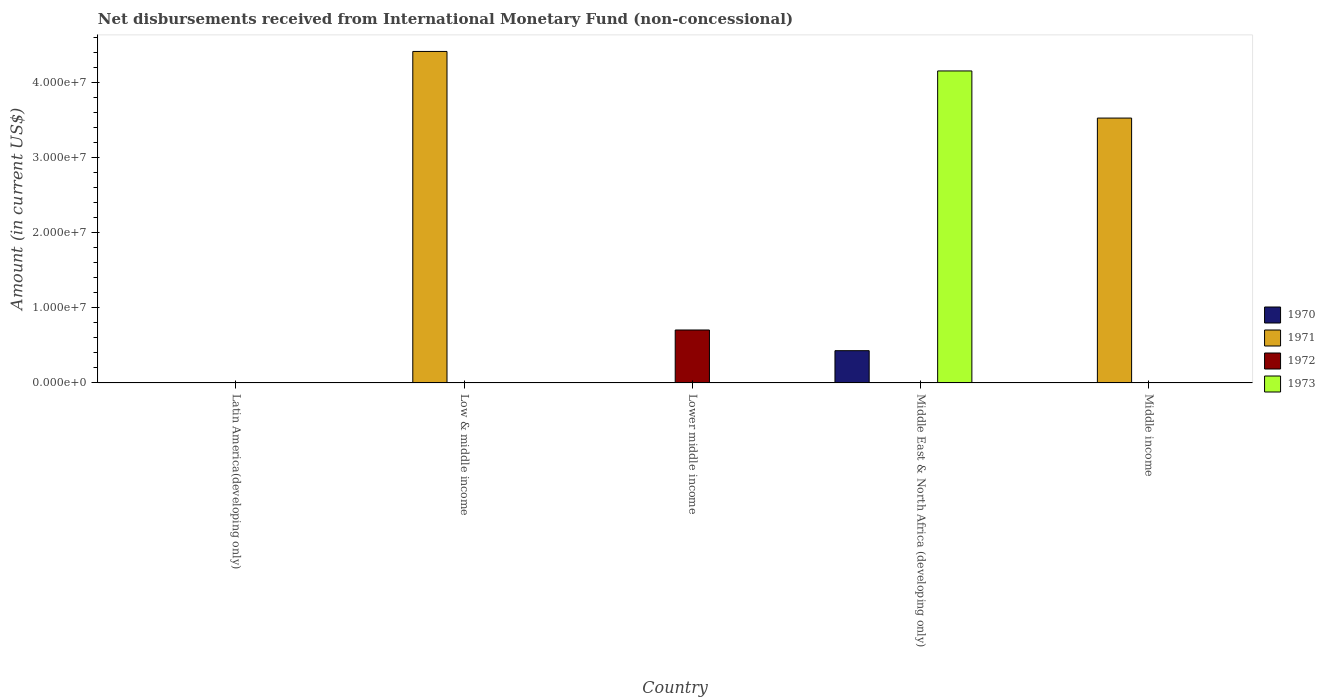How many different coloured bars are there?
Your answer should be compact. 4. What is the label of the 1st group of bars from the left?
Make the answer very short. Latin America(developing only). What is the amount of disbursements received from International Monetary Fund in 1970 in Lower middle income?
Keep it short and to the point. 0. Across all countries, what is the maximum amount of disbursements received from International Monetary Fund in 1973?
Offer a terse response. 4.16e+07. Across all countries, what is the minimum amount of disbursements received from International Monetary Fund in 1972?
Your answer should be very brief. 0. In which country was the amount of disbursements received from International Monetary Fund in 1970 maximum?
Offer a terse response. Middle East & North Africa (developing only). What is the total amount of disbursements received from International Monetary Fund in 1971 in the graph?
Your answer should be compact. 7.95e+07. What is the difference between the amount of disbursements received from International Monetary Fund in 1971 in Low & middle income and that in Middle income?
Offer a terse response. 8.88e+06. What is the difference between the amount of disbursements received from International Monetary Fund in 1972 in Latin America(developing only) and the amount of disbursements received from International Monetary Fund in 1970 in Low & middle income?
Keep it short and to the point. 0. What is the average amount of disbursements received from International Monetary Fund in 1970 per country?
Offer a very short reply. 8.60e+05. What is the difference between the amount of disbursements received from International Monetary Fund of/in 1973 and amount of disbursements received from International Monetary Fund of/in 1970 in Middle East & North Africa (developing only)?
Provide a succinct answer. 3.73e+07. What is the difference between the highest and the lowest amount of disbursements received from International Monetary Fund in 1970?
Ensure brevity in your answer.  4.30e+06. In how many countries, is the amount of disbursements received from International Monetary Fund in 1973 greater than the average amount of disbursements received from International Monetary Fund in 1973 taken over all countries?
Your answer should be compact. 1. Is it the case that in every country, the sum of the amount of disbursements received from International Monetary Fund in 1973 and amount of disbursements received from International Monetary Fund in 1970 is greater than the sum of amount of disbursements received from International Monetary Fund in 1972 and amount of disbursements received from International Monetary Fund in 1971?
Your response must be concise. No. Is it the case that in every country, the sum of the amount of disbursements received from International Monetary Fund in 1971 and amount of disbursements received from International Monetary Fund in 1972 is greater than the amount of disbursements received from International Monetary Fund in 1973?
Offer a terse response. No. Are all the bars in the graph horizontal?
Make the answer very short. No. Are the values on the major ticks of Y-axis written in scientific E-notation?
Make the answer very short. Yes. Does the graph contain any zero values?
Offer a very short reply. Yes. Does the graph contain grids?
Offer a terse response. No. Where does the legend appear in the graph?
Make the answer very short. Center right. What is the title of the graph?
Provide a short and direct response. Net disbursements received from International Monetary Fund (non-concessional). What is the label or title of the X-axis?
Give a very brief answer. Country. What is the label or title of the Y-axis?
Provide a short and direct response. Amount (in current US$). What is the Amount (in current US$) in 1970 in Latin America(developing only)?
Your answer should be very brief. 0. What is the Amount (in current US$) in 1971 in Latin America(developing only)?
Give a very brief answer. 0. What is the Amount (in current US$) in 1971 in Low & middle income?
Ensure brevity in your answer.  4.42e+07. What is the Amount (in current US$) of 1973 in Low & middle income?
Make the answer very short. 0. What is the Amount (in current US$) in 1970 in Lower middle income?
Provide a succinct answer. 0. What is the Amount (in current US$) in 1971 in Lower middle income?
Offer a very short reply. 0. What is the Amount (in current US$) in 1972 in Lower middle income?
Provide a succinct answer. 7.06e+06. What is the Amount (in current US$) in 1970 in Middle East & North Africa (developing only)?
Provide a short and direct response. 4.30e+06. What is the Amount (in current US$) of 1971 in Middle East & North Africa (developing only)?
Keep it short and to the point. 0. What is the Amount (in current US$) in 1973 in Middle East & North Africa (developing only)?
Offer a terse response. 4.16e+07. What is the Amount (in current US$) of 1970 in Middle income?
Provide a short and direct response. 0. What is the Amount (in current US$) of 1971 in Middle income?
Your answer should be very brief. 3.53e+07. Across all countries, what is the maximum Amount (in current US$) of 1970?
Make the answer very short. 4.30e+06. Across all countries, what is the maximum Amount (in current US$) in 1971?
Offer a terse response. 4.42e+07. Across all countries, what is the maximum Amount (in current US$) in 1972?
Ensure brevity in your answer.  7.06e+06. Across all countries, what is the maximum Amount (in current US$) in 1973?
Offer a terse response. 4.16e+07. Across all countries, what is the minimum Amount (in current US$) in 1972?
Offer a very short reply. 0. Across all countries, what is the minimum Amount (in current US$) in 1973?
Ensure brevity in your answer.  0. What is the total Amount (in current US$) of 1970 in the graph?
Offer a terse response. 4.30e+06. What is the total Amount (in current US$) of 1971 in the graph?
Offer a terse response. 7.95e+07. What is the total Amount (in current US$) in 1972 in the graph?
Make the answer very short. 7.06e+06. What is the total Amount (in current US$) in 1973 in the graph?
Provide a succinct answer. 4.16e+07. What is the difference between the Amount (in current US$) of 1971 in Low & middle income and that in Middle income?
Your response must be concise. 8.88e+06. What is the difference between the Amount (in current US$) in 1971 in Low & middle income and the Amount (in current US$) in 1972 in Lower middle income?
Make the answer very short. 3.71e+07. What is the difference between the Amount (in current US$) of 1971 in Low & middle income and the Amount (in current US$) of 1973 in Middle East & North Africa (developing only)?
Give a very brief answer. 2.60e+06. What is the difference between the Amount (in current US$) of 1972 in Lower middle income and the Amount (in current US$) of 1973 in Middle East & North Africa (developing only)?
Give a very brief answer. -3.45e+07. What is the difference between the Amount (in current US$) in 1970 in Middle East & North Africa (developing only) and the Amount (in current US$) in 1971 in Middle income?
Ensure brevity in your answer.  -3.10e+07. What is the average Amount (in current US$) of 1970 per country?
Offer a very short reply. 8.60e+05. What is the average Amount (in current US$) in 1971 per country?
Offer a very short reply. 1.59e+07. What is the average Amount (in current US$) of 1972 per country?
Your answer should be very brief. 1.41e+06. What is the average Amount (in current US$) of 1973 per country?
Keep it short and to the point. 8.32e+06. What is the difference between the Amount (in current US$) in 1970 and Amount (in current US$) in 1973 in Middle East & North Africa (developing only)?
Ensure brevity in your answer.  -3.73e+07. What is the ratio of the Amount (in current US$) of 1971 in Low & middle income to that in Middle income?
Offer a very short reply. 1.25. What is the difference between the highest and the lowest Amount (in current US$) in 1970?
Offer a very short reply. 4.30e+06. What is the difference between the highest and the lowest Amount (in current US$) of 1971?
Keep it short and to the point. 4.42e+07. What is the difference between the highest and the lowest Amount (in current US$) of 1972?
Give a very brief answer. 7.06e+06. What is the difference between the highest and the lowest Amount (in current US$) in 1973?
Your response must be concise. 4.16e+07. 